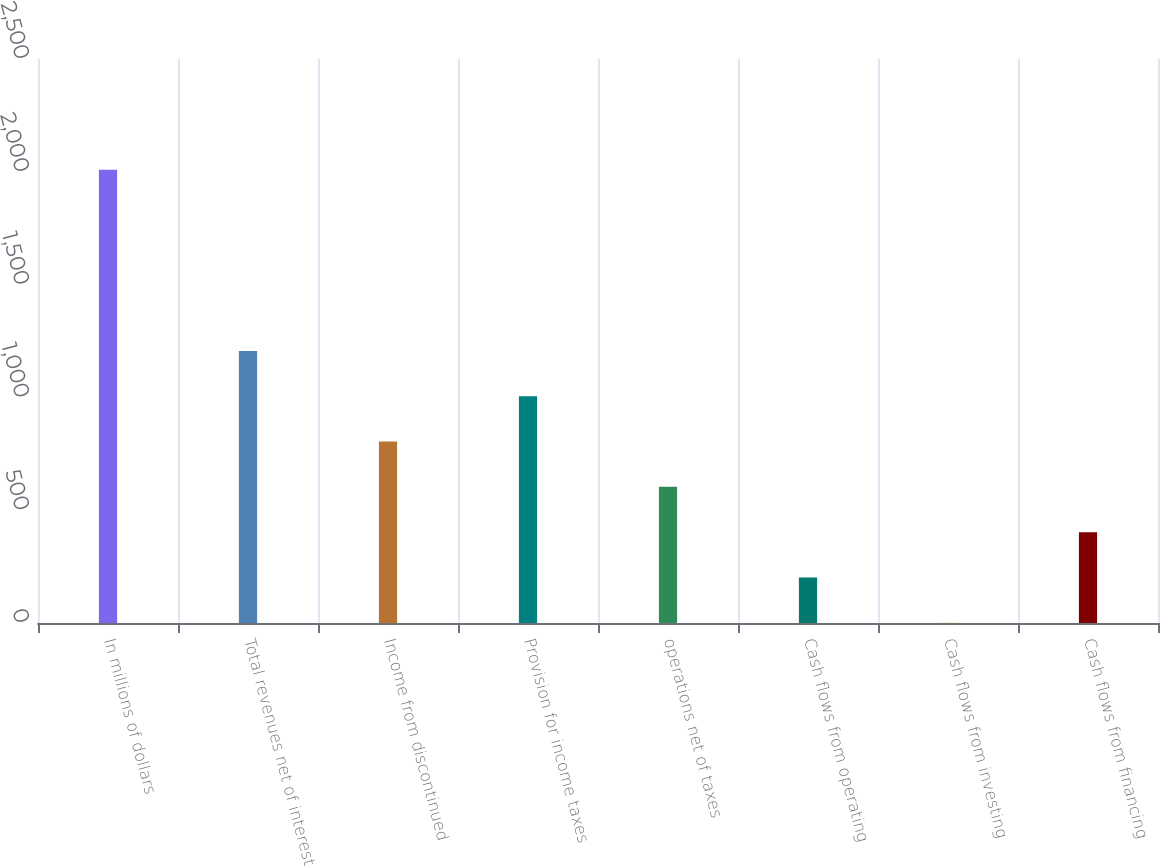Convert chart. <chart><loc_0><loc_0><loc_500><loc_500><bar_chart><fcel>In millions of dollars<fcel>Total revenues net of interest<fcel>Income from discontinued<fcel>Provision for income taxes<fcel>operations net of taxes<fcel>Cash flows from operating<fcel>Cash flows from investing<fcel>Cash flows from financing<nl><fcel>2009<fcel>1205.8<fcel>804.2<fcel>1005<fcel>603.4<fcel>201.8<fcel>1<fcel>402.6<nl></chart> 